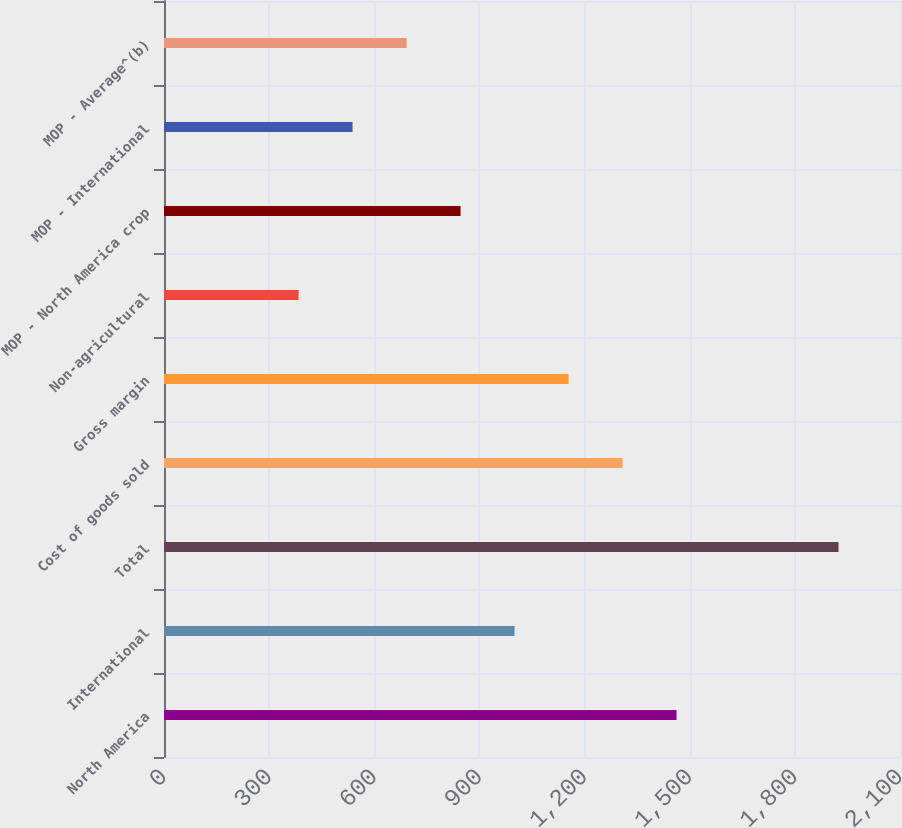Convert chart. <chart><loc_0><loc_0><loc_500><loc_500><bar_chart><fcel>North America<fcel>International<fcel>Total<fcel>Cost of goods sold<fcel>Gross margin<fcel>Non-agricultural<fcel>MOP - North America crop<fcel>MOP - International<fcel>MOP - Average^(b)<nl><fcel>1462.42<fcel>1000.24<fcel>1924.6<fcel>1308.36<fcel>1154.3<fcel>384<fcel>846.18<fcel>538.06<fcel>692.12<nl></chart> 